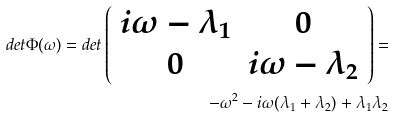<formula> <loc_0><loc_0><loc_500><loc_500>d e t \Phi ( \omega ) = d e t \left ( \begin{array} { c c } i \omega - \lambda _ { 1 } & 0 \\ 0 & i \omega - \lambda _ { 2 } \end{array} \right ) = \\ - \omega ^ { 2 } - i \omega ( \lambda _ { 1 } + \lambda _ { 2 } ) + \lambda _ { 1 } \lambda _ { 2 }</formula> 